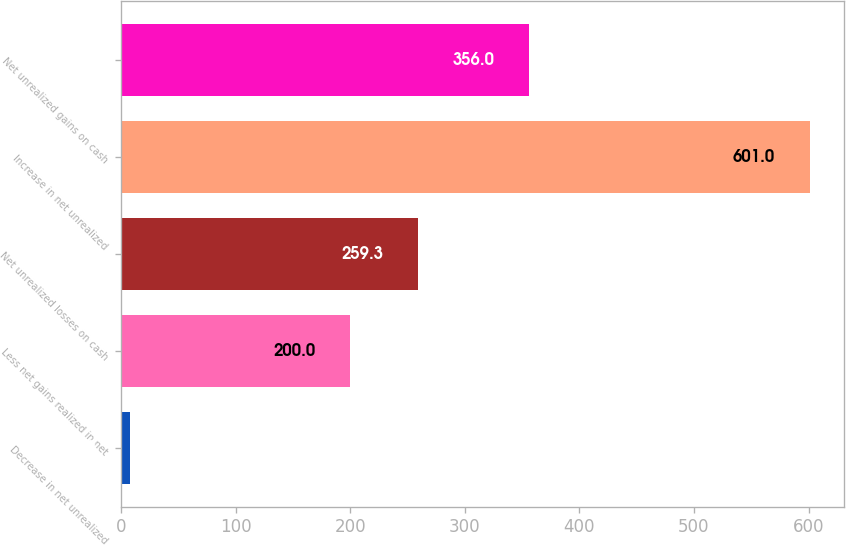<chart> <loc_0><loc_0><loc_500><loc_500><bar_chart><fcel>Decrease in net unrealized<fcel>Less net gains realized in net<fcel>Net unrealized losses on cash<fcel>Increase in net unrealized<fcel>Net unrealized gains on cash<nl><fcel>8<fcel>200<fcel>259.3<fcel>601<fcel>356<nl></chart> 